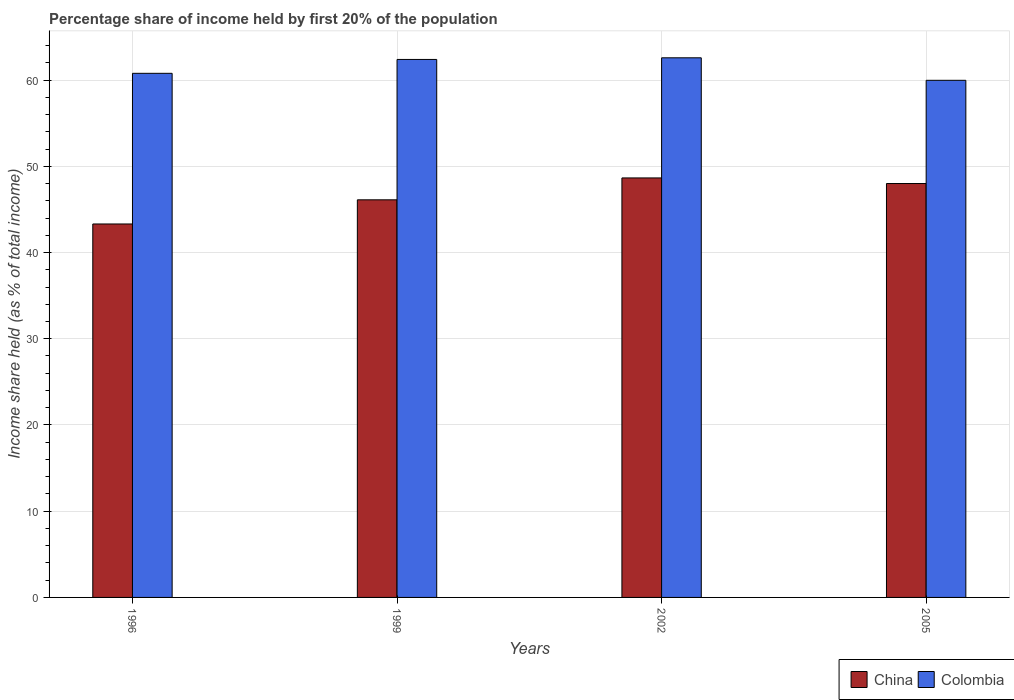How many bars are there on the 2nd tick from the left?
Offer a terse response. 2. In how many cases, is the number of bars for a given year not equal to the number of legend labels?
Offer a very short reply. 0. What is the share of income held by first 20% of the population in China in 2002?
Your response must be concise. 48.65. Across all years, what is the maximum share of income held by first 20% of the population in Colombia?
Offer a terse response. 62.58. Across all years, what is the minimum share of income held by first 20% of the population in China?
Offer a very short reply. 43.31. In which year was the share of income held by first 20% of the population in China maximum?
Your response must be concise. 2002. In which year was the share of income held by first 20% of the population in China minimum?
Give a very brief answer. 1996. What is the total share of income held by first 20% of the population in China in the graph?
Your answer should be compact. 186.07. What is the difference between the share of income held by first 20% of the population in China in 1996 and that in 2002?
Keep it short and to the point. -5.34. What is the difference between the share of income held by first 20% of the population in China in 2005 and the share of income held by first 20% of the population in Colombia in 1996?
Make the answer very short. -12.78. What is the average share of income held by first 20% of the population in Colombia per year?
Make the answer very short. 61.43. In the year 1999, what is the difference between the share of income held by first 20% of the population in China and share of income held by first 20% of the population in Colombia?
Provide a succinct answer. -16.28. What is the ratio of the share of income held by first 20% of the population in Colombia in 1996 to that in 2005?
Offer a very short reply. 1.01. What is the difference between the highest and the second highest share of income held by first 20% of the population in China?
Keep it short and to the point. 0.65. What is the difference between the highest and the lowest share of income held by first 20% of the population in Colombia?
Give a very brief answer. 2.61. What does the 1st bar from the left in 2005 represents?
Make the answer very short. China. What does the 2nd bar from the right in 1996 represents?
Your answer should be very brief. China. How many bars are there?
Provide a succinct answer. 8. What is the difference between two consecutive major ticks on the Y-axis?
Offer a terse response. 10. Does the graph contain grids?
Give a very brief answer. Yes. Where does the legend appear in the graph?
Provide a short and direct response. Bottom right. How are the legend labels stacked?
Your answer should be very brief. Horizontal. What is the title of the graph?
Make the answer very short. Percentage share of income held by first 20% of the population. What is the label or title of the Y-axis?
Offer a terse response. Income share held (as % of total income). What is the Income share held (as % of total income) in China in 1996?
Ensure brevity in your answer.  43.31. What is the Income share held (as % of total income) in Colombia in 1996?
Your response must be concise. 60.78. What is the Income share held (as % of total income) in China in 1999?
Your answer should be compact. 46.11. What is the Income share held (as % of total income) of Colombia in 1999?
Your answer should be compact. 62.39. What is the Income share held (as % of total income) in China in 2002?
Your answer should be compact. 48.65. What is the Income share held (as % of total income) of Colombia in 2002?
Your answer should be compact. 62.58. What is the Income share held (as % of total income) in Colombia in 2005?
Provide a succinct answer. 59.97. Across all years, what is the maximum Income share held (as % of total income) in China?
Make the answer very short. 48.65. Across all years, what is the maximum Income share held (as % of total income) of Colombia?
Keep it short and to the point. 62.58. Across all years, what is the minimum Income share held (as % of total income) of China?
Provide a succinct answer. 43.31. Across all years, what is the minimum Income share held (as % of total income) of Colombia?
Your response must be concise. 59.97. What is the total Income share held (as % of total income) in China in the graph?
Offer a terse response. 186.07. What is the total Income share held (as % of total income) of Colombia in the graph?
Your answer should be compact. 245.72. What is the difference between the Income share held (as % of total income) of China in 1996 and that in 1999?
Provide a succinct answer. -2.8. What is the difference between the Income share held (as % of total income) in Colombia in 1996 and that in 1999?
Offer a terse response. -1.61. What is the difference between the Income share held (as % of total income) of China in 1996 and that in 2002?
Provide a succinct answer. -5.34. What is the difference between the Income share held (as % of total income) of Colombia in 1996 and that in 2002?
Give a very brief answer. -1.8. What is the difference between the Income share held (as % of total income) in China in 1996 and that in 2005?
Your answer should be compact. -4.69. What is the difference between the Income share held (as % of total income) in Colombia in 1996 and that in 2005?
Your response must be concise. 0.81. What is the difference between the Income share held (as % of total income) in China in 1999 and that in 2002?
Make the answer very short. -2.54. What is the difference between the Income share held (as % of total income) in Colombia in 1999 and that in 2002?
Provide a short and direct response. -0.19. What is the difference between the Income share held (as % of total income) of China in 1999 and that in 2005?
Offer a terse response. -1.89. What is the difference between the Income share held (as % of total income) of Colombia in 1999 and that in 2005?
Ensure brevity in your answer.  2.42. What is the difference between the Income share held (as % of total income) of China in 2002 and that in 2005?
Your answer should be very brief. 0.65. What is the difference between the Income share held (as % of total income) of Colombia in 2002 and that in 2005?
Provide a succinct answer. 2.61. What is the difference between the Income share held (as % of total income) in China in 1996 and the Income share held (as % of total income) in Colombia in 1999?
Ensure brevity in your answer.  -19.08. What is the difference between the Income share held (as % of total income) of China in 1996 and the Income share held (as % of total income) of Colombia in 2002?
Provide a short and direct response. -19.27. What is the difference between the Income share held (as % of total income) in China in 1996 and the Income share held (as % of total income) in Colombia in 2005?
Provide a short and direct response. -16.66. What is the difference between the Income share held (as % of total income) of China in 1999 and the Income share held (as % of total income) of Colombia in 2002?
Give a very brief answer. -16.47. What is the difference between the Income share held (as % of total income) of China in 1999 and the Income share held (as % of total income) of Colombia in 2005?
Give a very brief answer. -13.86. What is the difference between the Income share held (as % of total income) in China in 2002 and the Income share held (as % of total income) in Colombia in 2005?
Keep it short and to the point. -11.32. What is the average Income share held (as % of total income) in China per year?
Your response must be concise. 46.52. What is the average Income share held (as % of total income) of Colombia per year?
Make the answer very short. 61.43. In the year 1996, what is the difference between the Income share held (as % of total income) in China and Income share held (as % of total income) in Colombia?
Keep it short and to the point. -17.47. In the year 1999, what is the difference between the Income share held (as % of total income) of China and Income share held (as % of total income) of Colombia?
Provide a short and direct response. -16.28. In the year 2002, what is the difference between the Income share held (as % of total income) of China and Income share held (as % of total income) of Colombia?
Provide a succinct answer. -13.93. In the year 2005, what is the difference between the Income share held (as % of total income) of China and Income share held (as % of total income) of Colombia?
Give a very brief answer. -11.97. What is the ratio of the Income share held (as % of total income) of China in 1996 to that in 1999?
Offer a terse response. 0.94. What is the ratio of the Income share held (as % of total income) of Colombia in 1996 to that in 1999?
Offer a very short reply. 0.97. What is the ratio of the Income share held (as % of total income) in China in 1996 to that in 2002?
Your answer should be very brief. 0.89. What is the ratio of the Income share held (as % of total income) in Colombia in 1996 to that in 2002?
Keep it short and to the point. 0.97. What is the ratio of the Income share held (as % of total income) of China in 1996 to that in 2005?
Make the answer very short. 0.9. What is the ratio of the Income share held (as % of total income) of Colombia in 1996 to that in 2005?
Offer a terse response. 1.01. What is the ratio of the Income share held (as % of total income) in China in 1999 to that in 2002?
Offer a very short reply. 0.95. What is the ratio of the Income share held (as % of total income) in China in 1999 to that in 2005?
Provide a succinct answer. 0.96. What is the ratio of the Income share held (as % of total income) in Colombia in 1999 to that in 2005?
Provide a short and direct response. 1.04. What is the ratio of the Income share held (as % of total income) in China in 2002 to that in 2005?
Keep it short and to the point. 1.01. What is the ratio of the Income share held (as % of total income) of Colombia in 2002 to that in 2005?
Make the answer very short. 1.04. What is the difference between the highest and the second highest Income share held (as % of total income) of China?
Provide a succinct answer. 0.65. What is the difference between the highest and the second highest Income share held (as % of total income) in Colombia?
Ensure brevity in your answer.  0.19. What is the difference between the highest and the lowest Income share held (as % of total income) of China?
Ensure brevity in your answer.  5.34. What is the difference between the highest and the lowest Income share held (as % of total income) of Colombia?
Give a very brief answer. 2.61. 